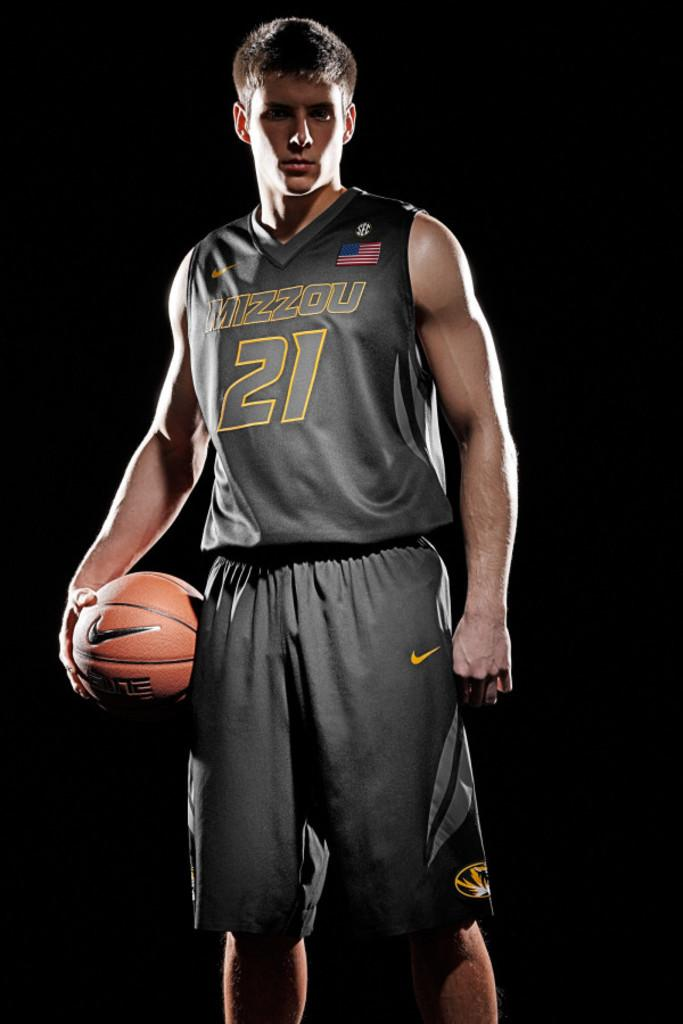<image>
Write a terse but informative summary of the picture. Player number 21 from Mizzou poses for a photo 